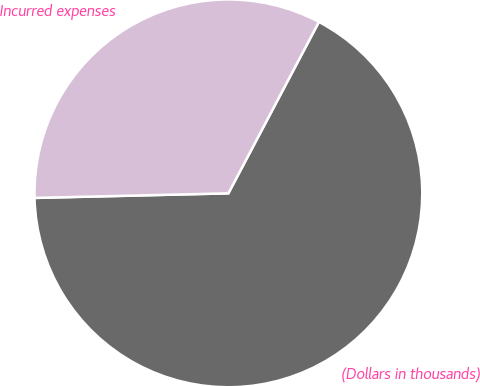Convert chart to OTSL. <chart><loc_0><loc_0><loc_500><loc_500><pie_chart><fcel>(Dollars in thousands)<fcel>Incurred expenses<nl><fcel>66.89%<fcel>33.11%<nl></chart> 